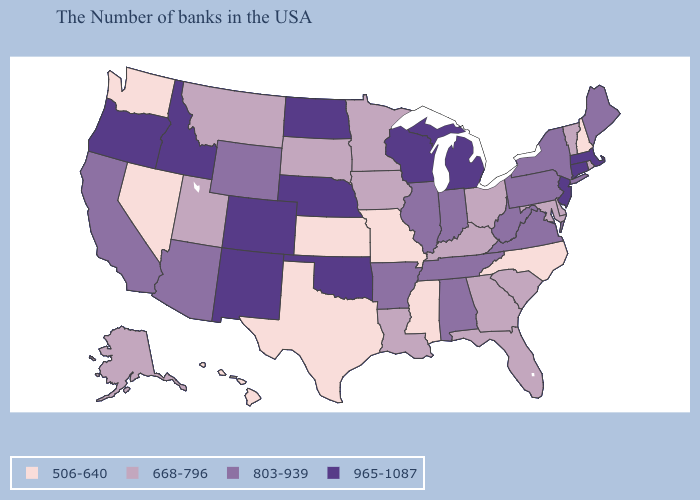Does New Mexico have the highest value in the USA?
Short answer required. Yes. Among the states that border New York , does Vermont have the lowest value?
Be succinct. Yes. Is the legend a continuous bar?
Answer briefly. No. What is the highest value in states that border Wyoming?
Write a very short answer. 965-1087. Does Missouri have a lower value than North Carolina?
Quick response, please. No. What is the lowest value in the USA?
Concise answer only. 506-640. Name the states that have a value in the range 803-939?
Answer briefly. Maine, New York, Pennsylvania, Virginia, West Virginia, Indiana, Alabama, Tennessee, Illinois, Arkansas, Wyoming, Arizona, California. What is the value of California?
Write a very short answer. 803-939. Among the states that border Minnesota , which have the highest value?
Answer briefly. Wisconsin, North Dakota. What is the value of Arkansas?
Write a very short answer. 803-939. Among the states that border California , does Nevada have the lowest value?
Write a very short answer. Yes. What is the value of Georgia?
Be succinct. 668-796. Among the states that border Ohio , does Kentucky have the lowest value?
Concise answer only. Yes. What is the highest value in the USA?
Concise answer only. 965-1087. 